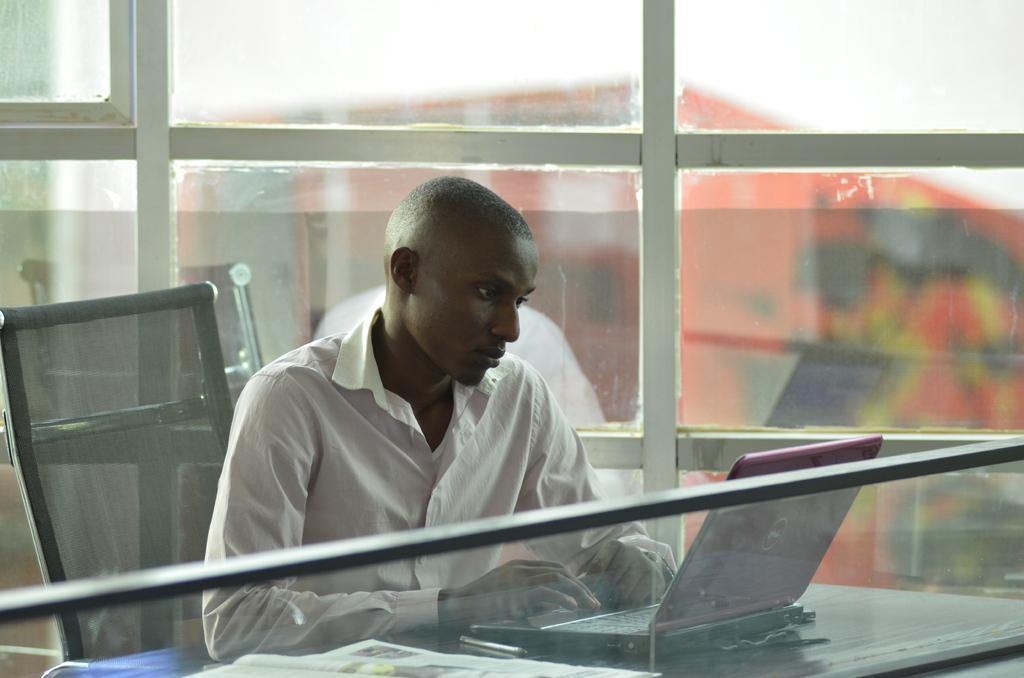Could you give a brief overview of what you see in this image? In this image I can see a person wearing white colored shirt is sitting on a chair in front of a desk and on the desk I can see a paper, a pen and a laptop. In the background I can see the glass window through which I can see a orange colored building and the sky. 